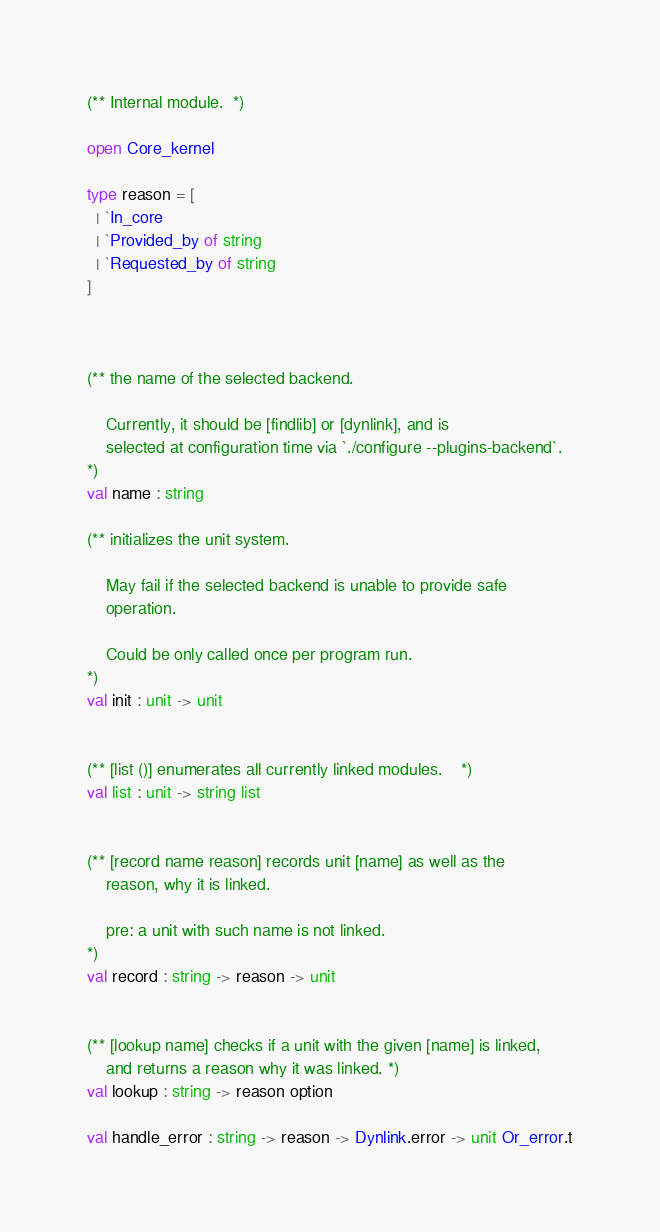<code> <loc_0><loc_0><loc_500><loc_500><_OCaml_>(** Internal module.  *)

open Core_kernel

type reason = [
  | `In_core
  | `Provided_by of string
  | `Requested_by of string
]



(** the name of the selected backend.

    Currently, it should be [findlib] or [dynlink], and is
    selected at configuration time via `./configure --plugins-backend`.
*)
val name : string

(** initializes the unit system.

    May fail if the selected backend is unable to provide safe
    operation.

    Could be only called once per program run.
*)
val init : unit -> unit


(** [list ()] enumerates all currently linked modules.    *)
val list : unit -> string list


(** [record name reason] records unit [name] as well as the
    reason, why it is linked.

    pre: a unit with such name is not linked.
*)
val record : string -> reason -> unit


(** [lookup name] checks if a unit with the given [name] is linked,
    and returns a reason why it was linked. *)
val lookup : string -> reason option

val handle_error : string -> reason -> Dynlink.error -> unit Or_error.t
</code> 